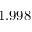Convert formula to latex. <formula><loc_0><loc_0><loc_500><loc_500>1 . 9 9 8</formula> 